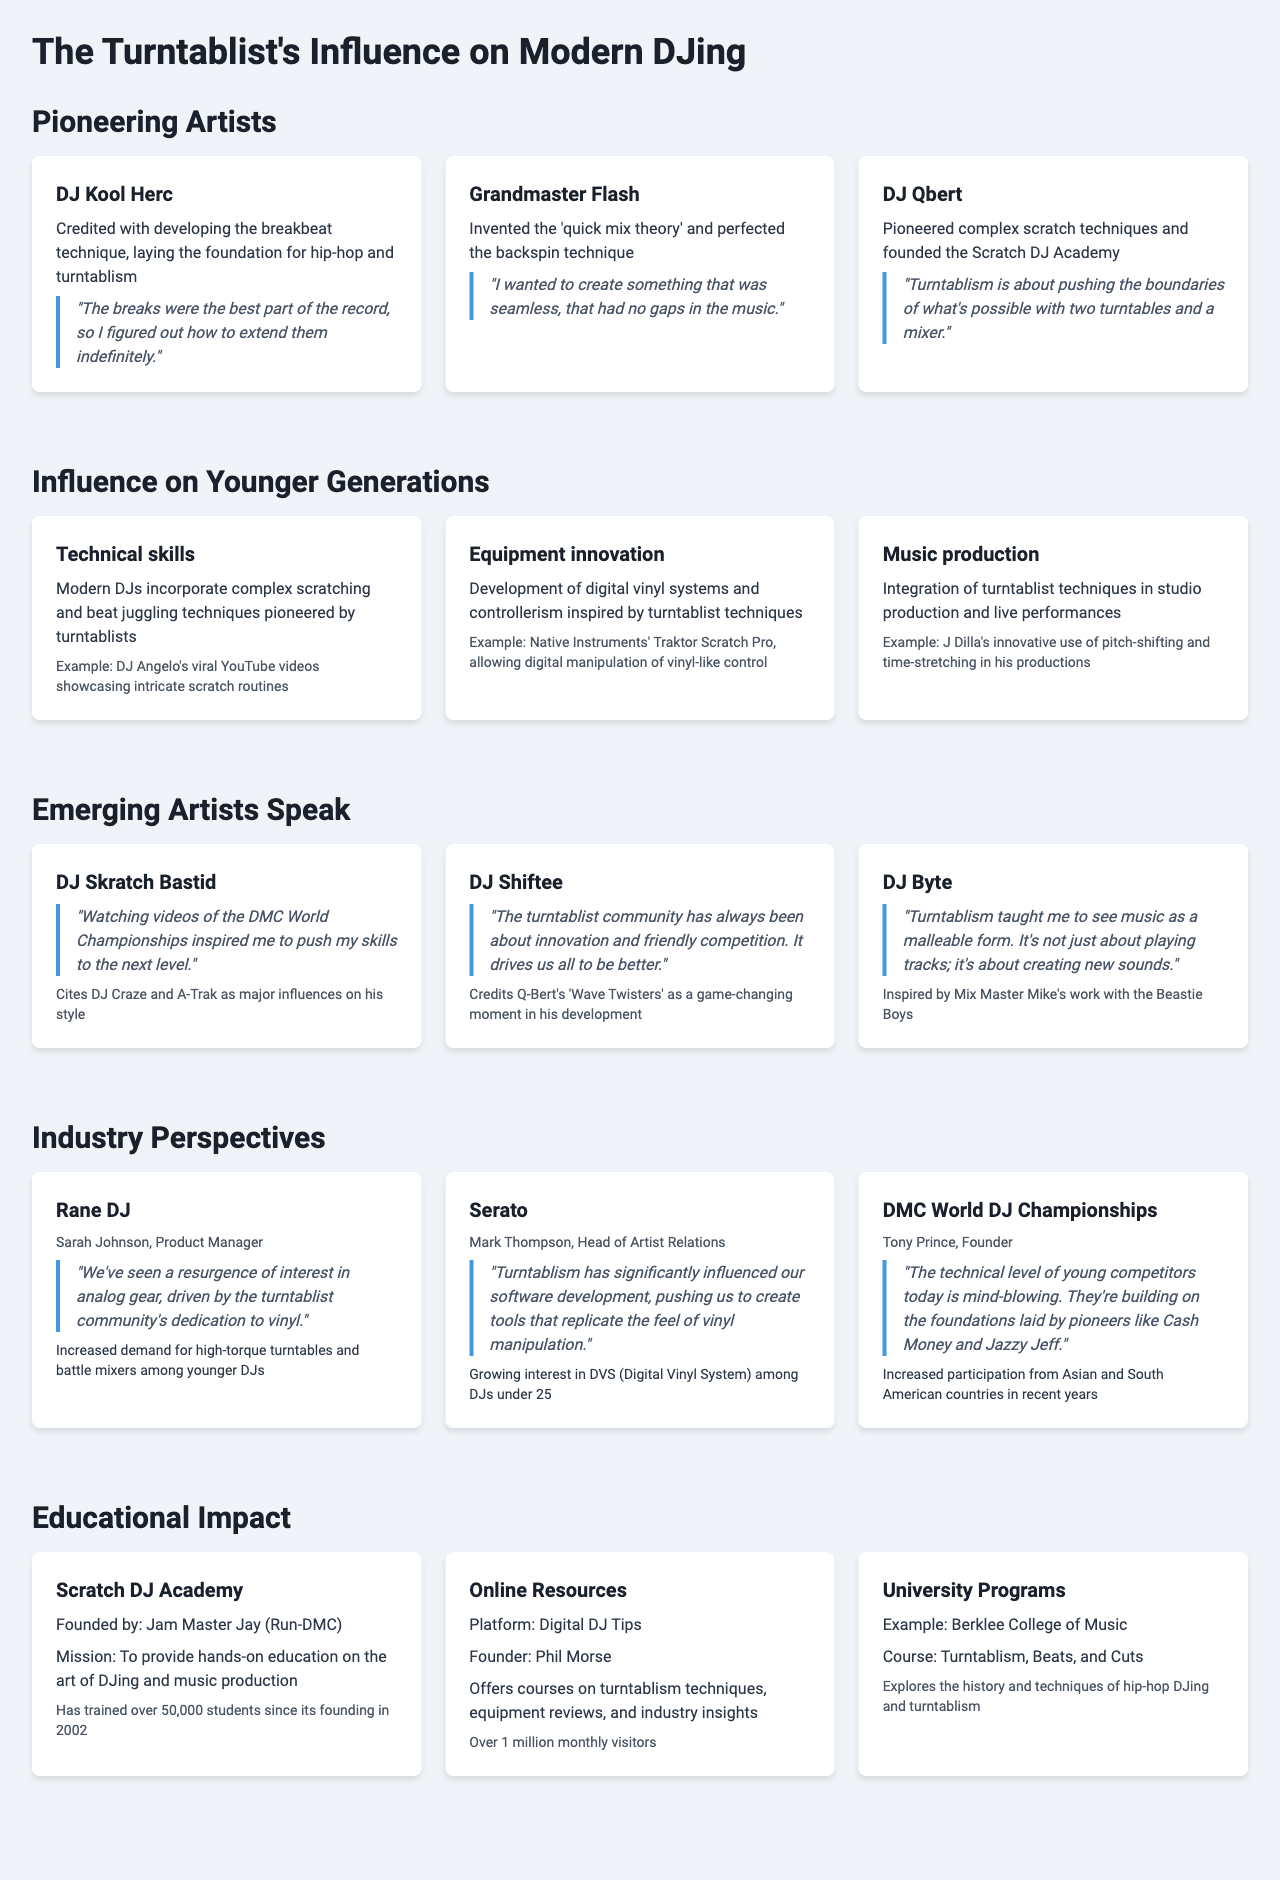What technique did DJ Kool Herc develop? DJ Kool Herc is credited with developing the breakbeat technique, laying the foundation for hip-hop and turntablism.
Answer: breakbeat technique Who founded the Scratch DJ Academy? The Scratch DJ Academy was founded by Jam Master Jay of Run-DMC.
Answer: Jam Master Jay What impact has the turntablist community had on equipment? The turntablist community has driven a resurgence of interest in analog gear, increasing demand for specific equipment among younger DJs.
Answer: resurgence of interest in analog gear Which emerging artist cites DJ Craze and A-Trak as influences? DJ Skratch Bastid cites DJ Craze and A-Trak as major influences on his style.
Answer: DJ Skratch Bastid What is the course taught at Berklee College of Music? The course at Berklee College of Music is titled "Turntablism, Beats, and Cuts."
Answer: Turntablism, Beats, and Cuts How many students has the Scratch DJ Academy trained? The Scratch DJ Academy has trained over 50,000 students since its founding in 2002.
Answer: over 50,000 students What did DJ Shiftee credit as a game-changing moment in his development? DJ Shiftee credits Q-Bert's "Wave Twisters" as a game-changing moment in his development.
Answer: Q-Bert's "Wave Twisters" What is the observation made by Serato regarding younger DJs? Serato observed a growing interest in Digital Vinyl Systems among DJs under 25.
Answer: growing interest in DVS among DJs under 25 What aspect of music production do modern DJs integrate from turntablism? Modern DJs integrate turntablist techniques in studio production and live performances.
Answer: studio production and live performances 